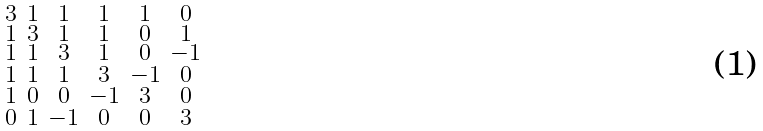<formula> <loc_0><loc_0><loc_500><loc_500>\begin{smallmatrix} 3 & 1 & 1 & 1 & 1 & 0 \\ 1 & 3 & 1 & 1 & 0 & 1 \\ 1 & 1 & 3 & 1 & 0 & - 1 \\ 1 & 1 & 1 & 3 & - 1 & 0 \\ 1 & 0 & 0 & - 1 & 3 & 0 \\ 0 & 1 & - 1 & 0 & 0 & 3 \end{smallmatrix}</formula> 